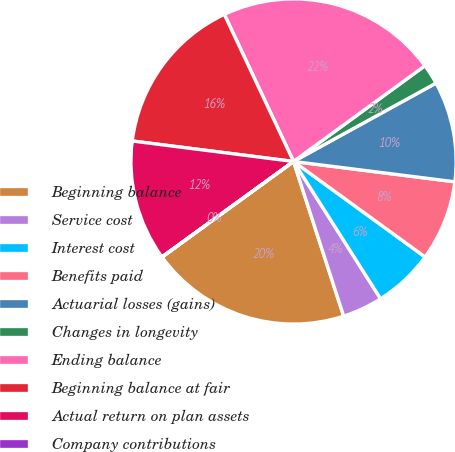Convert chart to OTSL. <chart><loc_0><loc_0><loc_500><loc_500><pie_chart><fcel>Beginning balance<fcel>Service cost<fcel>Interest cost<fcel>Benefits paid<fcel>Actuarial losses (gains)<fcel>Changes in longevity<fcel>Ending balance<fcel>Beginning balance at fair<fcel>Actual return on plan assets<fcel>Company contributions<nl><fcel>19.98%<fcel>4.01%<fcel>6.01%<fcel>8.0%<fcel>10.0%<fcel>2.02%<fcel>21.98%<fcel>15.99%<fcel>12.0%<fcel>0.02%<nl></chart> 